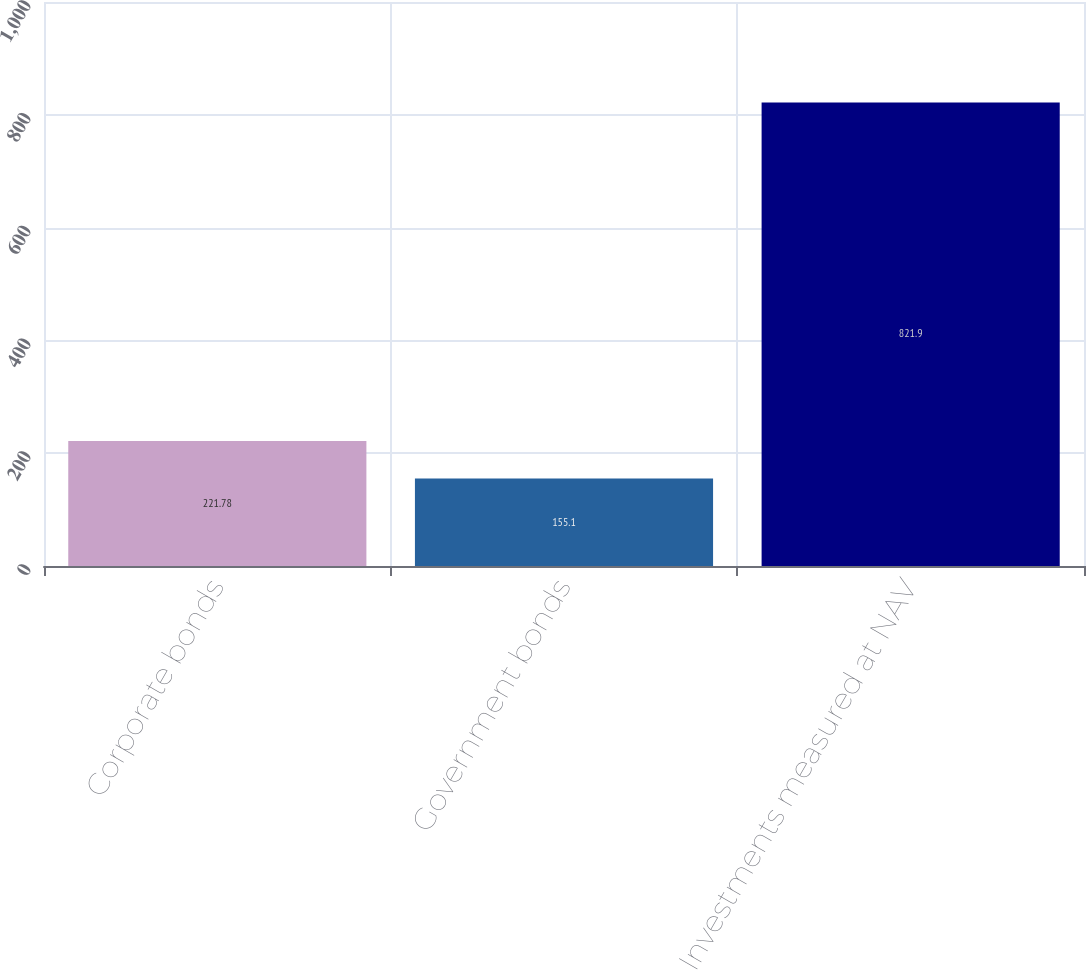Convert chart. <chart><loc_0><loc_0><loc_500><loc_500><bar_chart><fcel>Corporate bonds<fcel>Government bonds<fcel>Investments measured at NAV<nl><fcel>221.78<fcel>155.1<fcel>821.9<nl></chart> 